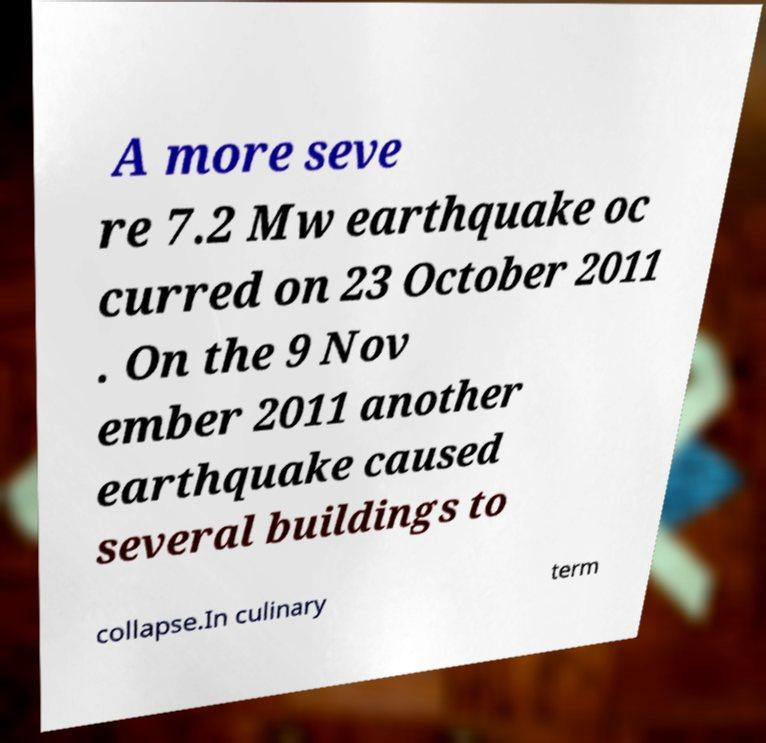For documentation purposes, I need the text within this image transcribed. Could you provide that? A more seve re 7.2 Mw earthquake oc curred on 23 October 2011 . On the 9 Nov ember 2011 another earthquake caused several buildings to collapse.In culinary term 